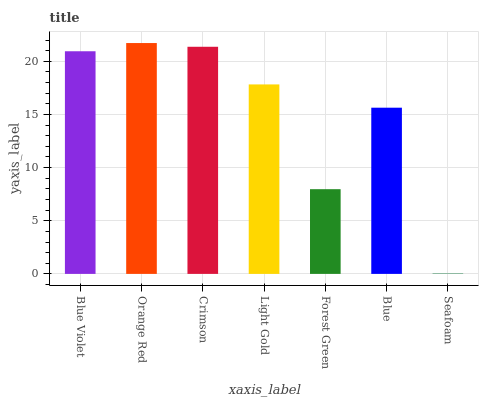Is Seafoam the minimum?
Answer yes or no. Yes. Is Orange Red the maximum?
Answer yes or no. Yes. Is Crimson the minimum?
Answer yes or no. No. Is Crimson the maximum?
Answer yes or no. No. Is Orange Red greater than Crimson?
Answer yes or no. Yes. Is Crimson less than Orange Red?
Answer yes or no. Yes. Is Crimson greater than Orange Red?
Answer yes or no. No. Is Orange Red less than Crimson?
Answer yes or no. No. Is Light Gold the high median?
Answer yes or no. Yes. Is Light Gold the low median?
Answer yes or no. Yes. Is Blue Violet the high median?
Answer yes or no. No. Is Seafoam the low median?
Answer yes or no. No. 